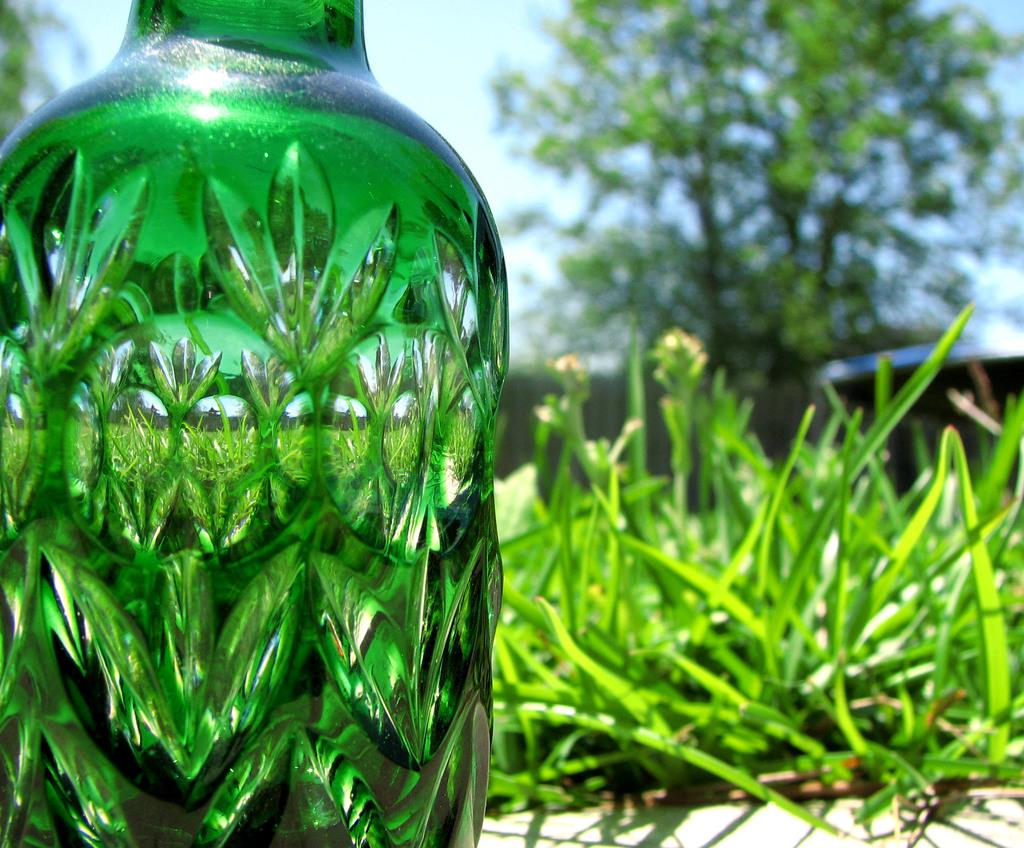What object is located in the foreground of the image? There is a bottle in the foreground of the image. What type of natural environment is visible in the background of the image? There is grass and trees visible in the background of the image. How many chairs can be seen in the image? There are no chairs present in the image. What type of needle is used to sew the grass in the image? There is no needle or sewing involved in the image; it features a bottle in the foreground and grass and trees in the background. 